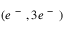Convert formula to latex. <formula><loc_0><loc_0><loc_500><loc_500>( e ^ { - } , 3 e ^ { - } )</formula> 